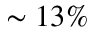<formula> <loc_0><loc_0><loc_500><loc_500>\sim 1 3 \%</formula> 